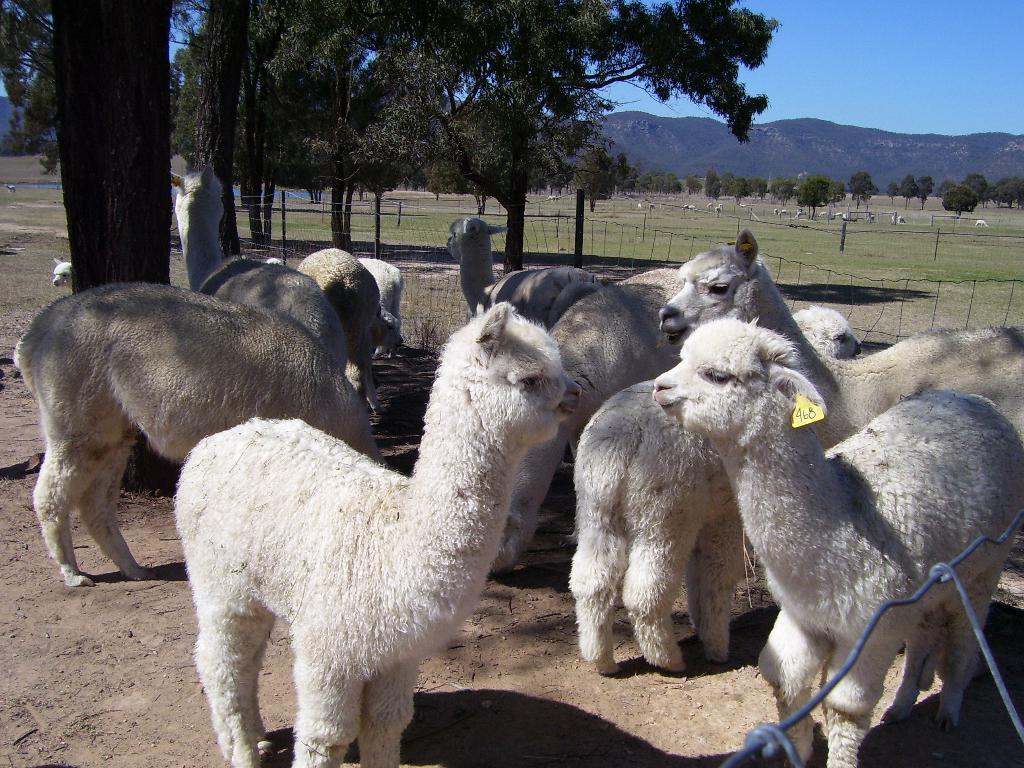What is the main subject of the image? There are animals standing in the image. What type of vegetation is present in the image? There is a green tree in the image. What is visible at the top of the image? The sky is visible at the top of the image. How many feathers can be seen on the animals in the image? There are no feathers visible on the animals in the image. Can you describe the animals jumping in the image? There is no indication that the animals are jumping in the image; they are standing. 